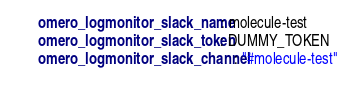<code> <loc_0><loc_0><loc_500><loc_500><_YAML_>      omero_logmonitor_slack_name: molecule-test
      omero_logmonitor_slack_token: DUMMY_TOKEN
      omero_logmonitor_slack_channel: "#molecule-test"
</code> 